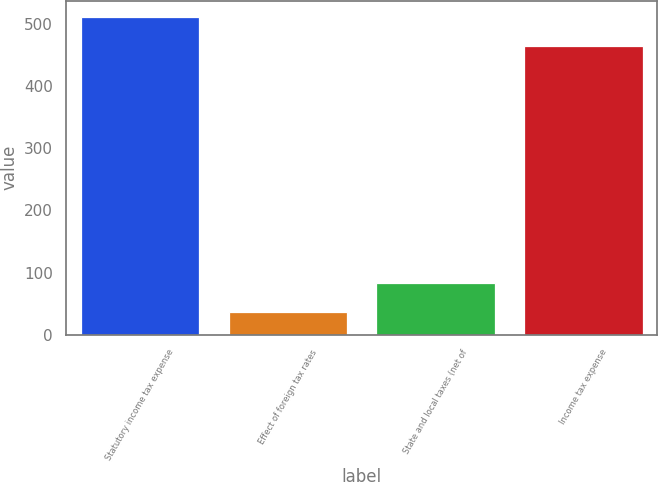Convert chart to OTSL. <chart><loc_0><loc_0><loc_500><loc_500><bar_chart><fcel>Statutory income tax expense<fcel>Effect of foreign tax rates<fcel>State and local taxes (net of<fcel>Income tax expense<nl><fcel>511.5<fcel>36<fcel>83.5<fcel>464<nl></chart> 